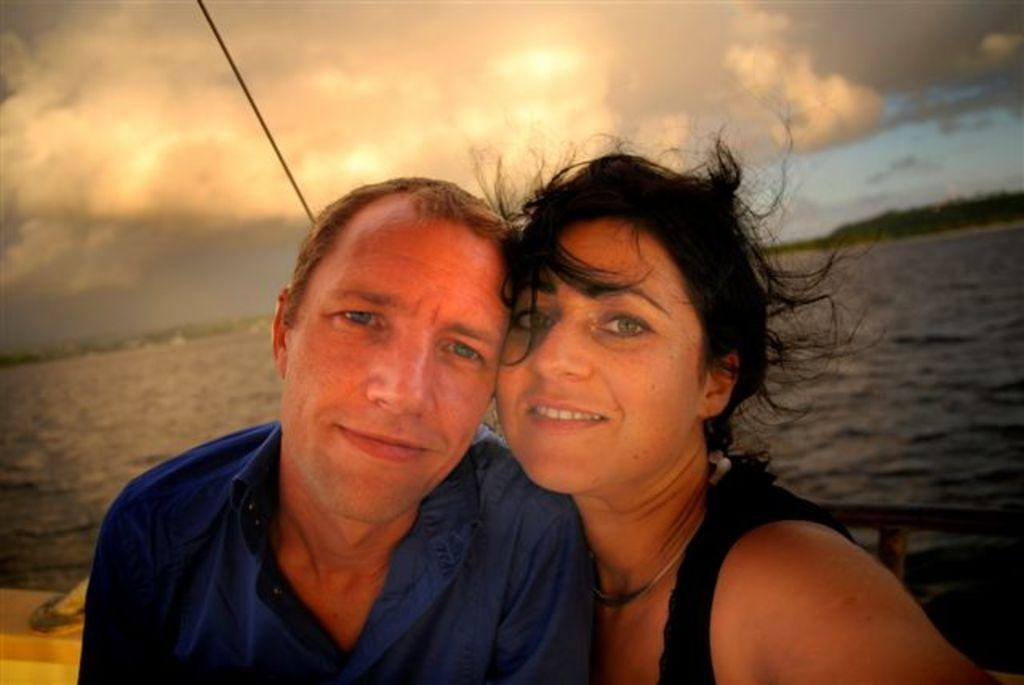Who is present in the image? There is a man and a woman in the image. What are the expressions of the people in the image? Both the man and the woman are smiling. What natural elements can be seen in the image? There is water and trees visible in the image. What is visible in the background of the image? The sky with clouds is visible in the background of the image. What type of brick pattern can be seen on the woman's dress in the image? There is no brick pattern visible on the woman's dress in the image. How many spots are present on the man's shirt in the image? There are no spots visible on the man's shirt in the image. 